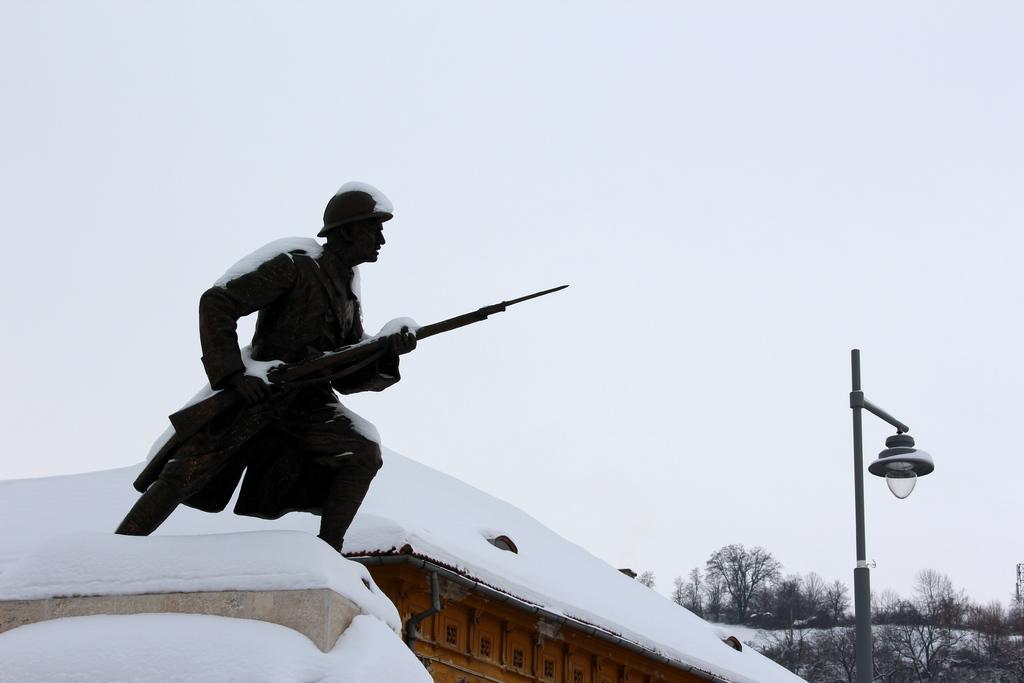Describe this image in one or two sentences. As we can see in the image there is a house, snow, statue, street lamp, trees and sky. 